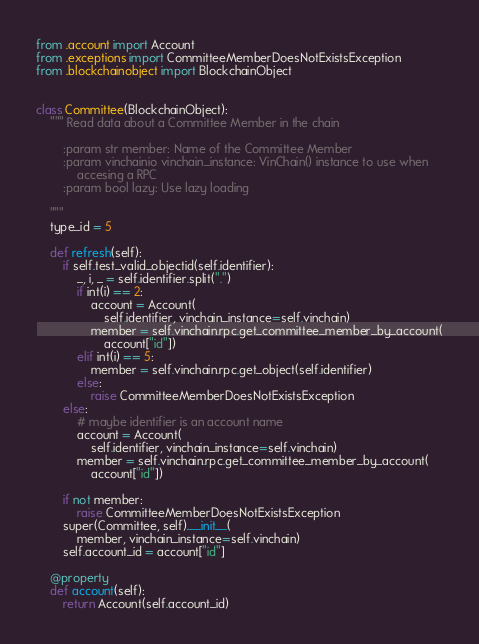<code> <loc_0><loc_0><loc_500><loc_500><_Python_>from .account import Account
from .exceptions import CommitteeMemberDoesNotExistsException
from .blockchainobject import BlockchainObject


class Committee(BlockchainObject):
    """ Read data about a Committee Member in the chain

        :param str member: Name of the Committee Member
        :param vinchainio vinchain_instance: VinChain() instance to use when
            accesing a RPC
        :param bool lazy: Use lazy loading

    """
    type_id = 5

    def refresh(self):
        if self.test_valid_objectid(self.identifier):
            _, i, _ = self.identifier.split(".")
            if int(i) == 2:
                account = Account(
                    self.identifier, vinchain_instance=self.vinchain)
                member = self.vinchain.rpc.get_committee_member_by_account(
                    account["id"])
            elif int(i) == 5:
                member = self.vinchain.rpc.get_object(self.identifier)
            else:
                raise CommitteeMemberDoesNotExistsException
        else:
            # maybe identifier is an account name
            account = Account(
                self.identifier, vinchain_instance=self.vinchain)
            member = self.vinchain.rpc.get_committee_member_by_account(
                account["id"])

        if not member:
            raise CommitteeMemberDoesNotExistsException
        super(Committee, self).__init__(
            member, vinchain_instance=self.vinchain)
        self.account_id = account["id"]

    @property
    def account(self):
        return Account(self.account_id)
</code> 